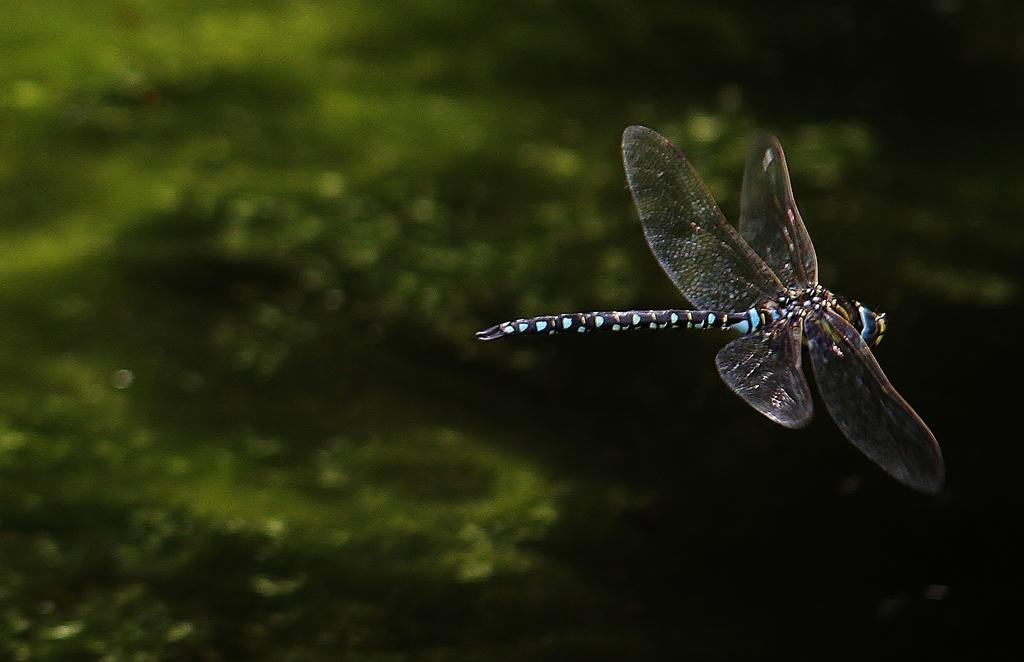What is the main subject of the image? There is a dragonfly in the image. Where is the dragonfly located? The dragonfly is in the air. What can be seen in the background of the image? There are plants in the background of the image. How would you describe the quality of the image? The image is slightly blurry. How many sheep are visible in the image? There are no sheep present in the image; it features a dragonfly in the air. What type of soap is being used to clean the oven in the image? There is no soap or oven present in the image; it focuses on a dragonfly in the air and plants in the background. 